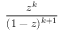Convert formula to latex. <formula><loc_0><loc_0><loc_500><loc_500>\frac { z ^ { k } } { ( 1 - z ) ^ { k + 1 } }</formula> 